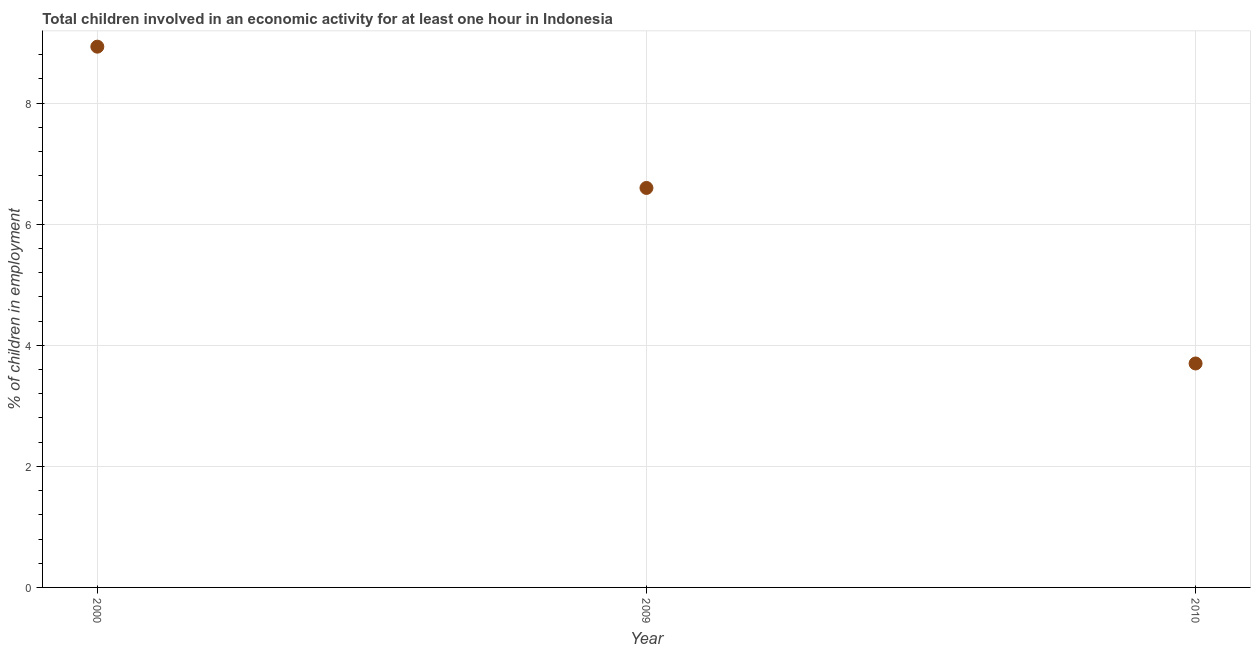What is the percentage of children in employment in 2010?
Provide a short and direct response. 3.7. Across all years, what is the maximum percentage of children in employment?
Keep it short and to the point. 8.93. Across all years, what is the minimum percentage of children in employment?
Ensure brevity in your answer.  3.7. What is the sum of the percentage of children in employment?
Offer a terse response. 19.23. What is the difference between the percentage of children in employment in 2000 and 2009?
Keep it short and to the point. 2.33. What is the average percentage of children in employment per year?
Ensure brevity in your answer.  6.41. What is the median percentage of children in employment?
Your answer should be compact. 6.6. What is the ratio of the percentage of children in employment in 2000 to that in 2010?
Your answer should be compact. 2.41. Is the percentage of children in employment in 2000 less than that in 2009?
Offer a terse response. No. Is the difference between the percentage of children in employment in 2000 and 2009 greater than the difference between any two years?
Ensure brevity in your answer.  No. What is the difference between the highest and the second highest percentage of children in employment?
Ensure brevity in your answer.  2.33. Is the sum of the percentage of children in employment in 2000 and 2009 greater than the maximum percentage of children in employment across all years?
Provide a succinct answer. Yes. What is the difference between the highest and the lowest percentage of children in employment?
Your answer should be very brief. 5.23. How many dotlines are there?
Your answer should be compact. 1. What is the difference between two consecutive major ticks on the Y-axis?
Provide a short and direct response. 2. Are the values on the major ticks of Y-axis written in scientific E-notation?
Offer a terse response. No. What is the title of the graph?
Offer a very short reply. Total children involved in an economic activity for at least one hour in Indonesia. What is the label or title of the X-axis?
Provide a short and direct response. Year. What is the label or title of the Y-axis?
Keep it short and to the point. % of children in employment. What is the % of children in employment in 2000?
Ensure brevity in your answer.  8.93. What is the % of children in employment in 2009?
Keep it short and to the point. 6.6. What is the % of children in employment in 2010?
Your answer should be very brief. 3.7. What is the difference between the % of children in employment in 2000 and 2009?
Offer a terse response. 2.33. What is the difference between the % of children in employment in 2000 and 2010?
Your answer should be very brief. 5.23. What is the difference between the % of children in employment in 2009 and 2010?
Offer a terse response. 2.9. What is the ratio of the % of children in employment in 2000 to that in 2009?
Make the answer very short. 1.35. What is the ratio of the % of children in employment in 2000 to that in 2010?
Ensure brevity in your answer.  2.42. What is the ratio of the % of children in employment in 2009 to that in 2010?
Make the answer very short. 1.78. 